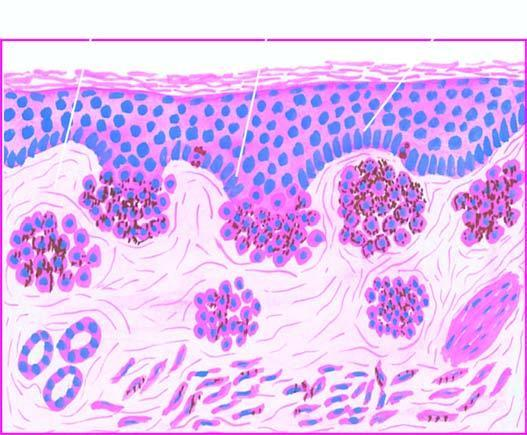what contain coarse, granular, brown-black melanin pigment?
Answer the question using a single word or phrase. These cells 